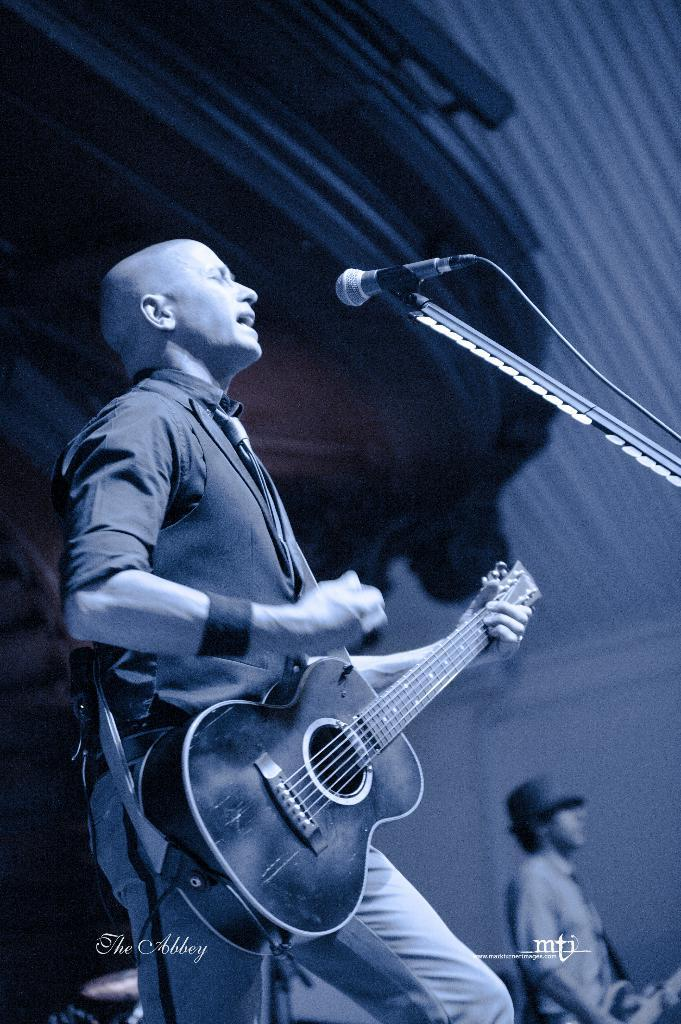What is the man in the image doing? The man in the image is singing and playing a guitar. What object is in front of the man? There is a microphone in front of the man. Can you describe the second man in the image? The second man is in the background of the image and is also playing a guitar. What type of honey is being used to fuel the engine in the image? There is no engine or honey present in the image; it features two men playing guitars and singing. What is the kettle being used for in the image? There is no kettle present in the image. 